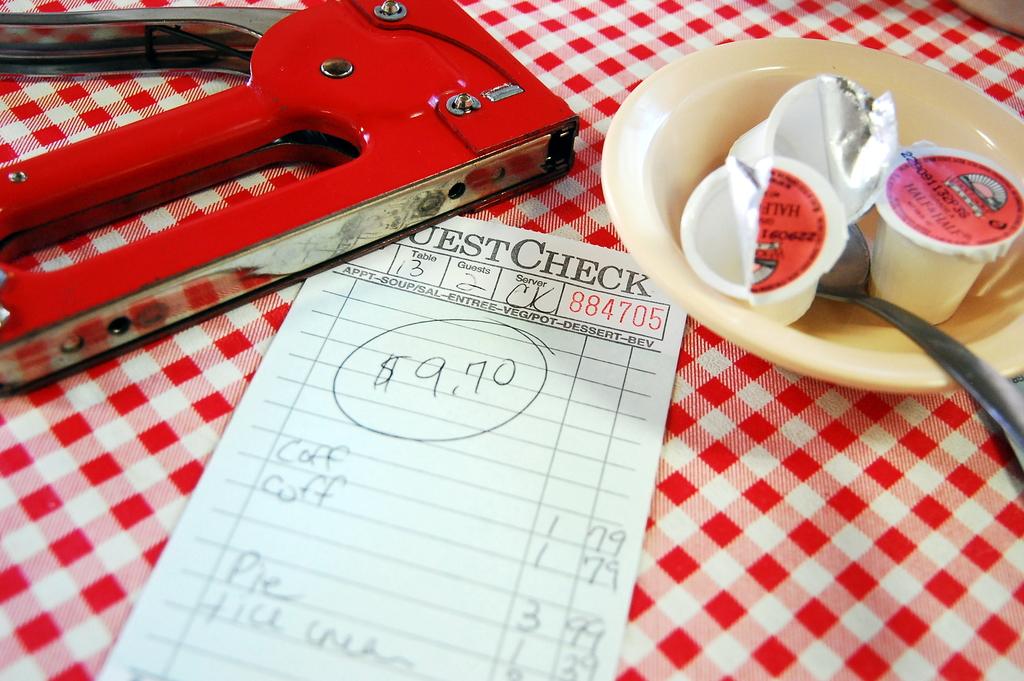What's the check total?
Provide a succinct answer. $9.70. How much were the coffees?
Ensure brevity in your answer.  1.79. 